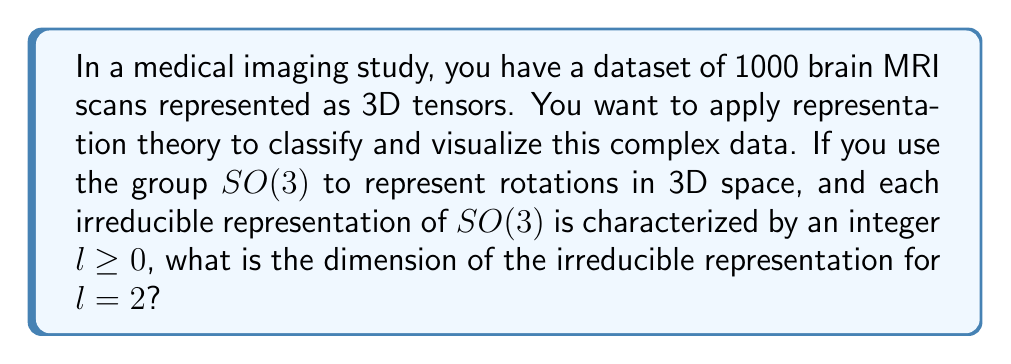Show me your answer to this math problem. To solve this problem, we'll follow these steps:

1) In representation theory, the group $SO(3)$ represents rotations in 3D space. This is relevant for 3D medical imaging data like brain MRI scans.

2) The irreducible representations of $SO(3)$ are characterized by a non-negative integer $l$, often called the angular momentum quantum number in physics.

3) For $SO(3)$, the dimension of the irreducible representation for a given $l$ is given by the formula:

   $$d_l = 2l + 1$$

4) In this case, we're asked about $l = 2$. Let's substitute this into the formula:

   $$d_2 = 2(2) + 1 = 4 + 1 = 5$$

5) Therefore, the dimension of the irreducible representation for $l = 2$ is 5.

This result is important for data scientists working with 3D medical imaging data because it tells us how many independent components we need to represent rotations of order 2 in our data. This can be used for feature extraction, dimensionality reduction, or building invariant representations of the brain MRI scans.
Answer: 5 